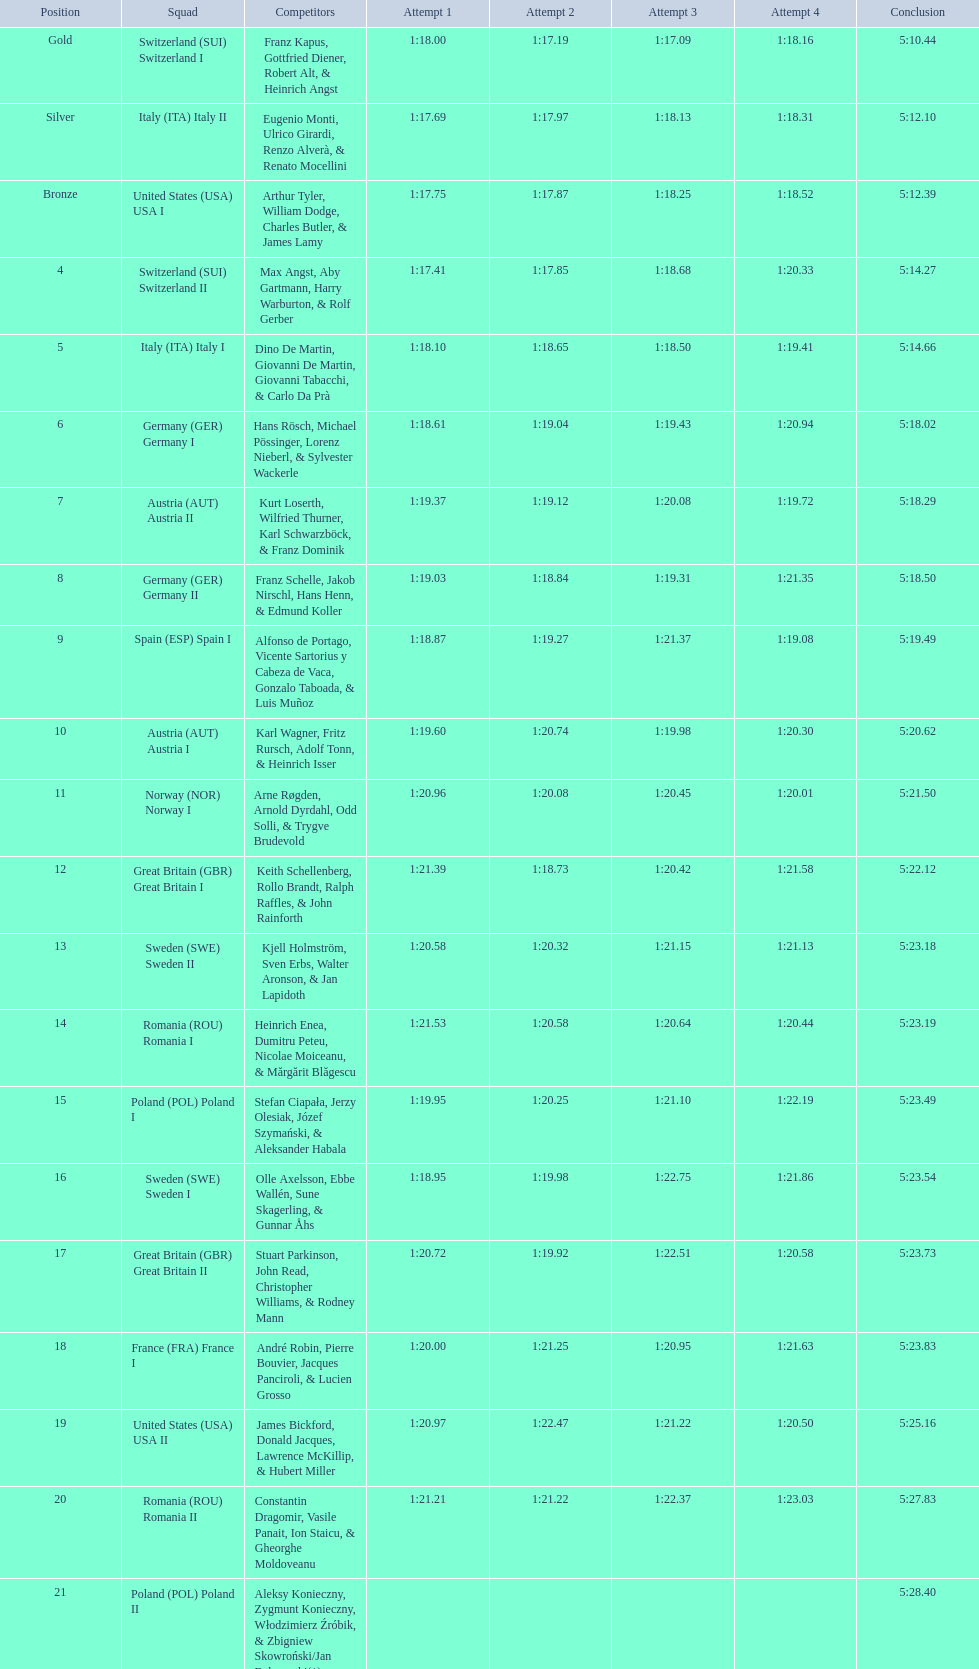Who placed the highest, italy or germany? Italy. 